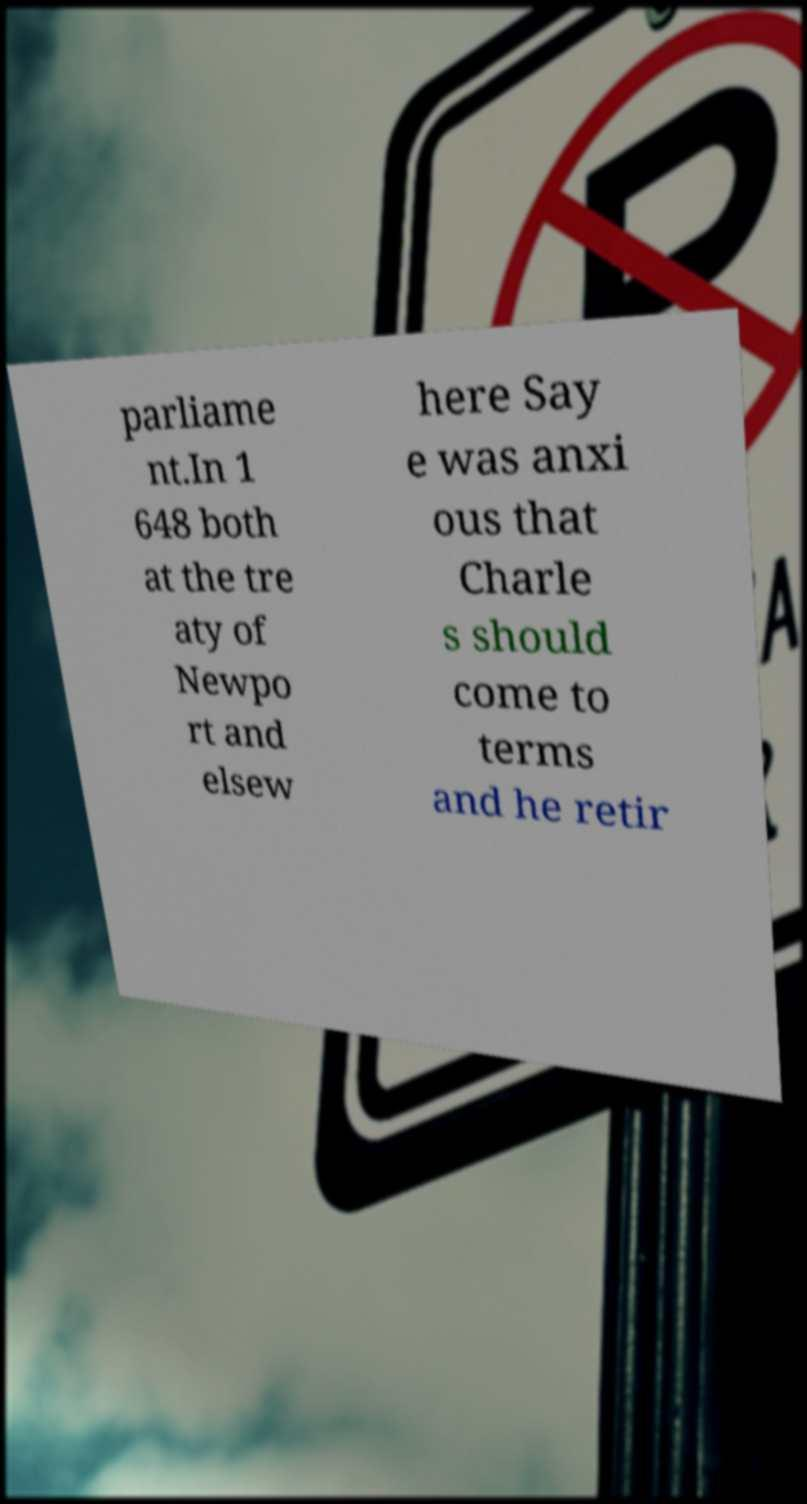There's text embedded in this image that I need extracted. Can you transcribe it verbatim? parliame nt.In 1 648 both at the tre aty of Newpo rt and elsew here Say e was anxi ous that Charle s should come to terms and he retir 